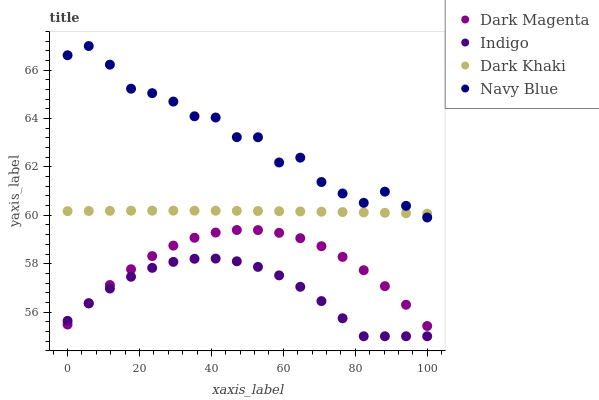Does Indigo have the minimum area under the curve?
Answer yes or no. Yes. Does Navy Blue have the maximum area under the curve?
Answer yes or no. Yes. Does Navy Blue have the minimum area under the curve?
Answer yes or no. No. Does Indigo have the maximum area under the curve?
Answer yes or no. No. Is Dark Khaki the smoothest?
Answer yes or no. Yes. Is Navy Blue the roughest?
Answer yes or no. Yes. Is Indigo the smoothest?
Answer yes or no. No. Is Indigo the roughest?
Answer yes or no. No. Does Indigo have the lowest value?
Answer yes or no. Yes. Does Navy Blue have the lowest value?
Answer yes or no. No. Does Navy Blue have the highest value?
Answer yes or no. Yes. Does Indigo have the highest value?
Answer yes or no. No. Is Indigo less than Navy Blue?
Answer yes or no. Yes. Is Dark Khaki greater than Indigo?
Answer yes or no. Yes. Does Dark Khaki intersect Navy Blue?
Answer yes or no. Yes. Is Dark Khaki less than Navy Blue?
Answer yes or no. No. Is Dark Khaki greater than Navy Blue?
Answer yes or no. No. Does Indigo intersect Navy Blue?
Answer yes or no. No. 